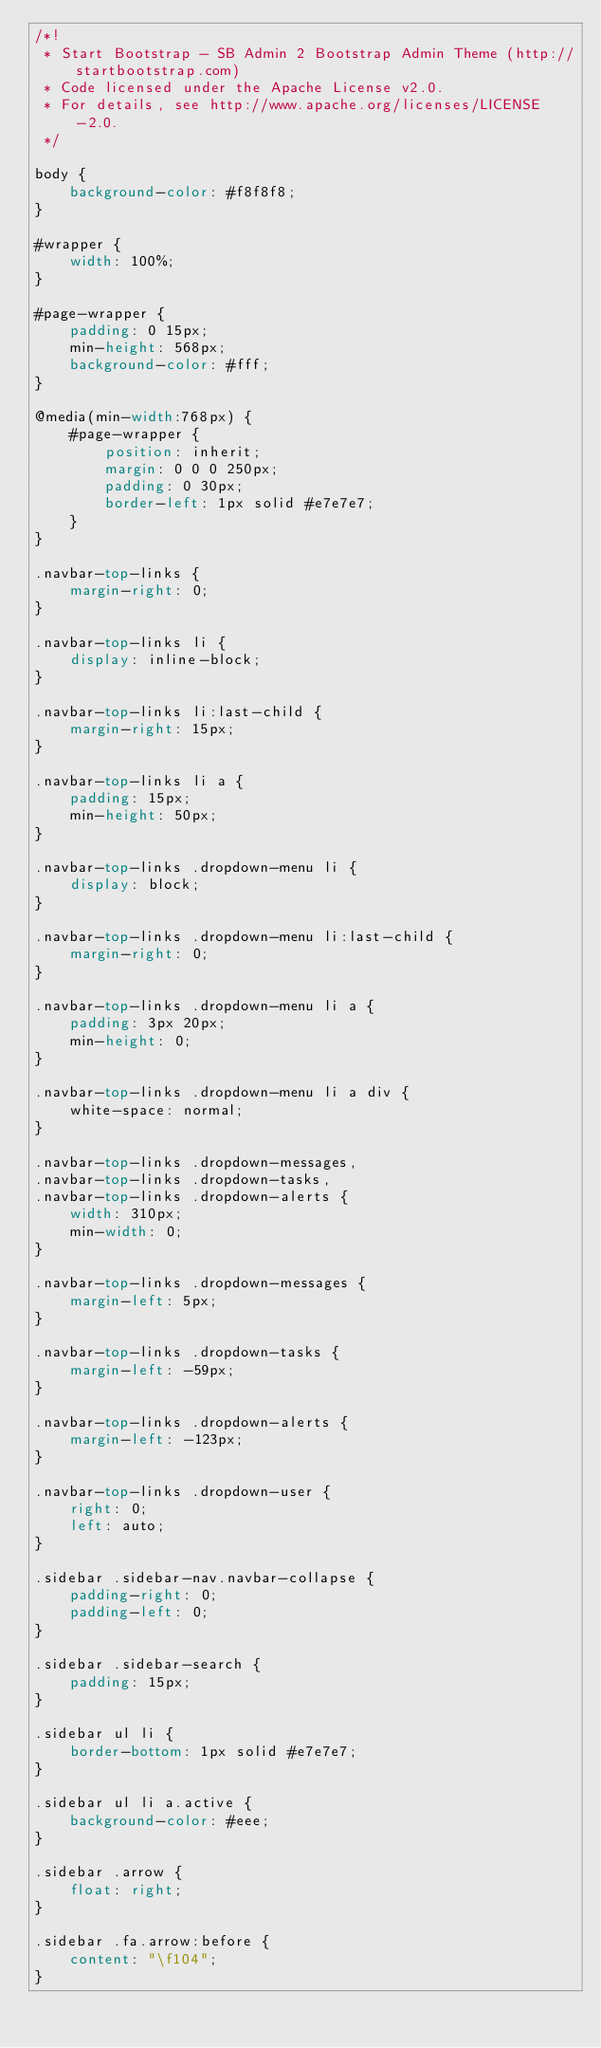Convert code to text. <code><loc_0><loc_0><loc_500><loc_500><_CSS_>/*!
 * Start Bootstrap - SB Admin 2 Bootstrap Admin Theme (http://startbootstrap.com)
 * Code licensed under the Apache License v2.0.
 * For details, see http://www.apache.org/licenses/LICENSE-2.0.
 */

body {
    background-color: #f8f8f8;
}

#wrapper {
    width: 100%;
}

#page-wrapper {
    padding: 0 15px;
    min-height: 568px;
    background-color: #fff;
}

@media(min-width:768px) {
    #page-wrapper {
        position: inherit;
        margin: 0 0 0 250px;
        padding: 0 30px;
        border-left: 1px solid #e7e7e7;
    }
}

.navbar-top-links {
    margin-right: 0;
}

.navbar-top-links li {
    display: inline-block;
}

.navbar-top-links li:last-child {
    margin-right: 15px;
}

.navbar-top-links li a {
    padding: 15px;
    min-height: 50px;
}

.navbar-top-links .dropdown-menu li {
    display: block;
}

.navbar-top-links .dropdown-menu li:last-child {
    margin-right: 0;
}

.navbar-top-links .dropdown-menu li a {
    padding: 3px 20px;
    min-height: 0;
}

.navbar-top-links .dropdown-menu li a div {
    white-space: normal;
}

.navbar-top-links .dropdown-messages,
.navbar-top-links .dropdown-tasks,
.navbar-top-links .dropdown-alerts {
    width: 310px;
    min-width: 0;
}

.navbar-top-links .dropdown-messages {
    margin-left: 5px;
}

.navbar-top-links .dropdown-tasks {
    margin-left: -59px;
}

.navbar-top-links .dropdown-alerts {
    margin-left: -123px;
}

.navbar-top-links .dropdown-user {
    right: 0;
    left: auto;
}

.sidebar .sidebar-nav.navbar-collapse {
    padding-right: 0;
    padding-left: 0;
}

.sidebar .sidebar-search {
    padding: 15px;
}

.sidebar ul li {
    border-bottom: 1px solid #e7e7e7;
}

.sidebar ul li a.active {
    background-color: #eee;
}

.sidebar .arrow {
    float: right;
}

.sidebar .fa.arrow:before {
    content: "\f104";
}
</code> 